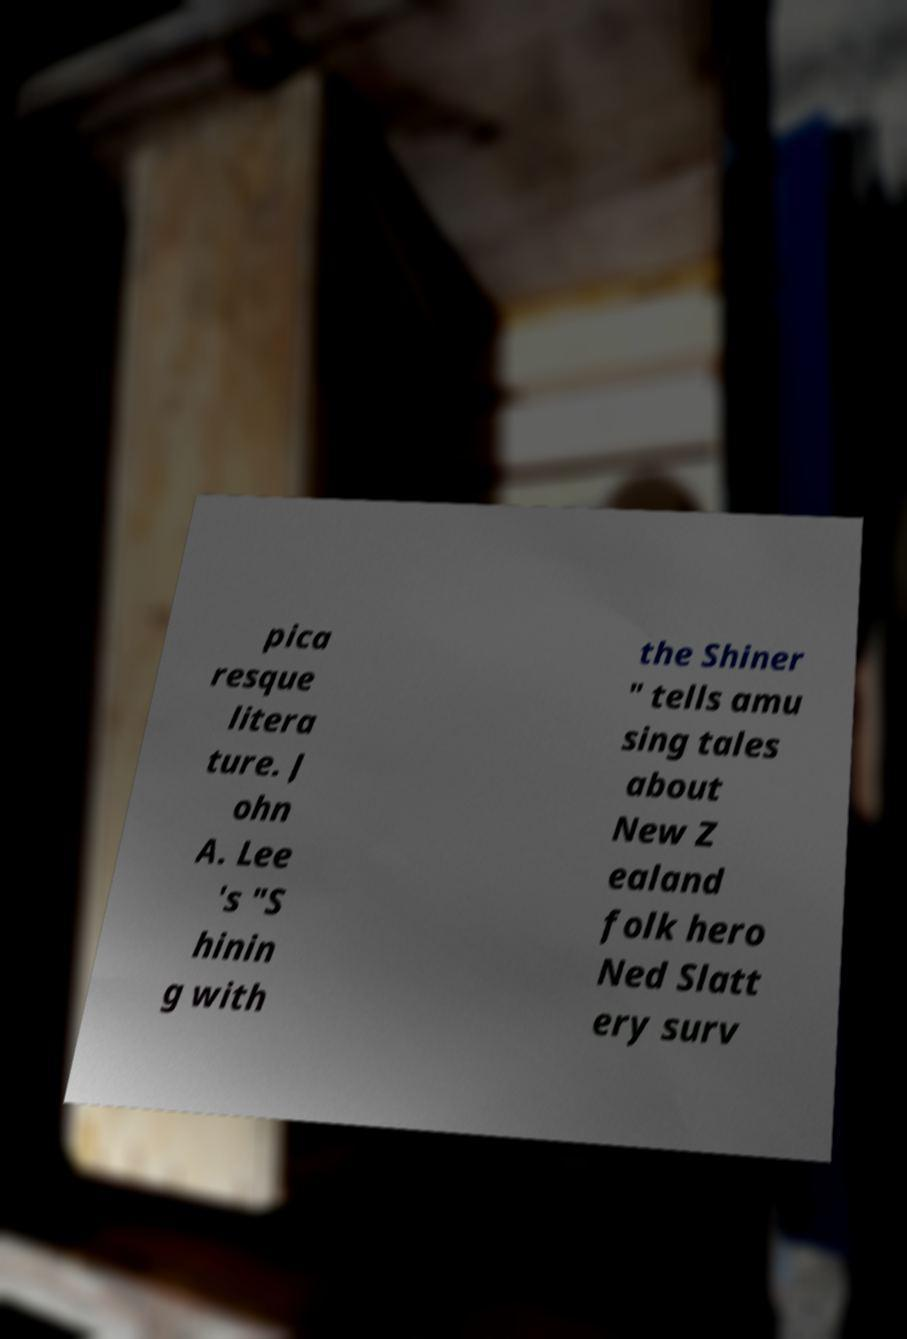I need the written content from this picture converted into text. Can you do that? pica resque litera ture. J ohn A. Lee 's "S hinin g with the Shiner " tells amu sing tales about New Z ealand folk hero Ned Slatt ery surv 